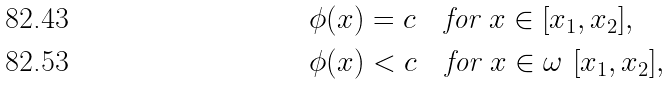Convert formula to latex. <formula><loc_0><loc_0><loc_500><loc_500>& \phi ( x ) = c \quad \text {for } x \in [ x _ { 1 } , x _ { 2 } ] , \\ & \phi ( x ) < c \quad \text {for } x \in \omega \ [ x _ { 1 } , x _ { 2 } ] ,</formula> 